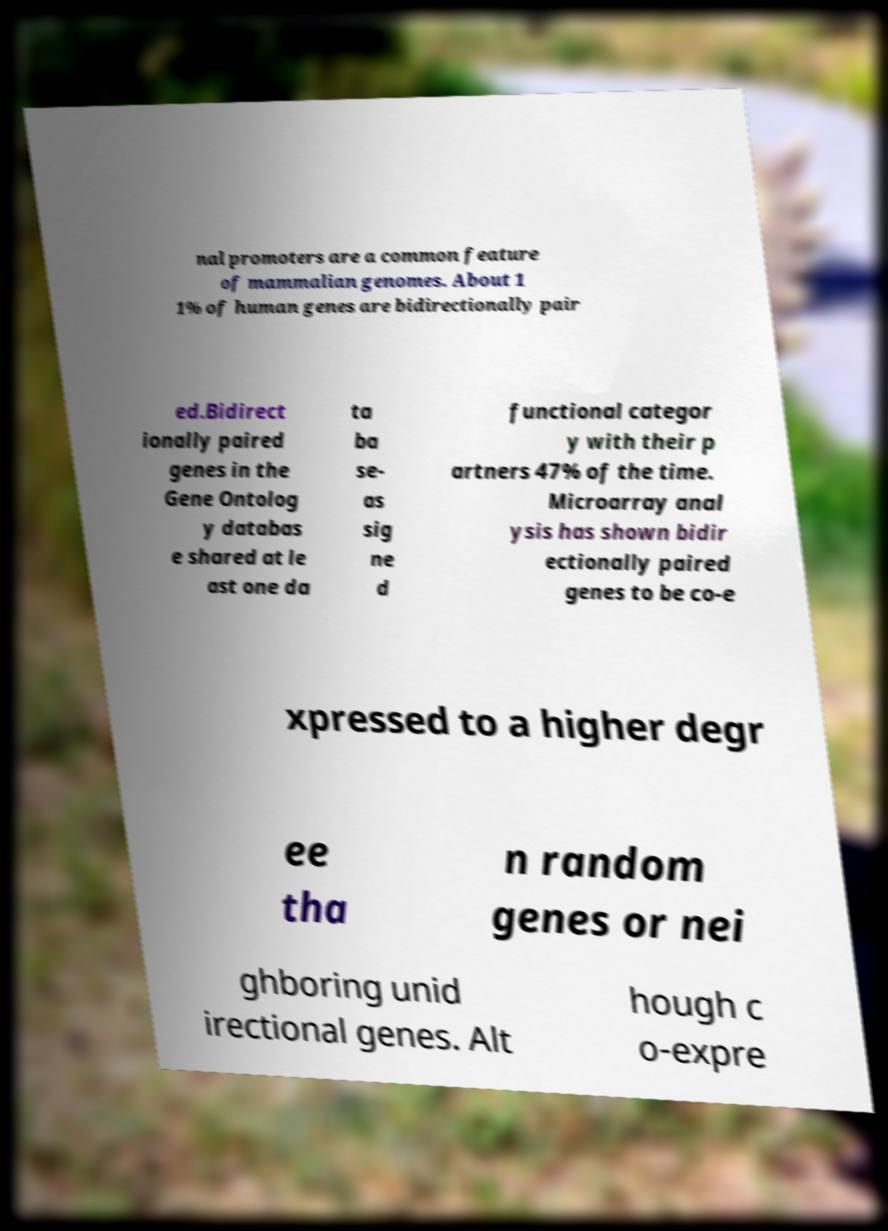Could you assist in decoding the text presented in this image and type it out clearly? nal promoters are a common feature of mammalian genomes. About 1 1% of human genes are bidirectionally pair ed.Bidirect ionally paired genes in the Gene Ontolog y databas e shared at le ast one da ta ba se- as sig ne d functional categor y with their p artners 47% of the time. Microarray anal ysis has shown bidir ectionally paired genes to be co-e xpressed to a higher degr ee tha n random genes or nei ghboring unid irectional genes. Alt hough c o-expre 